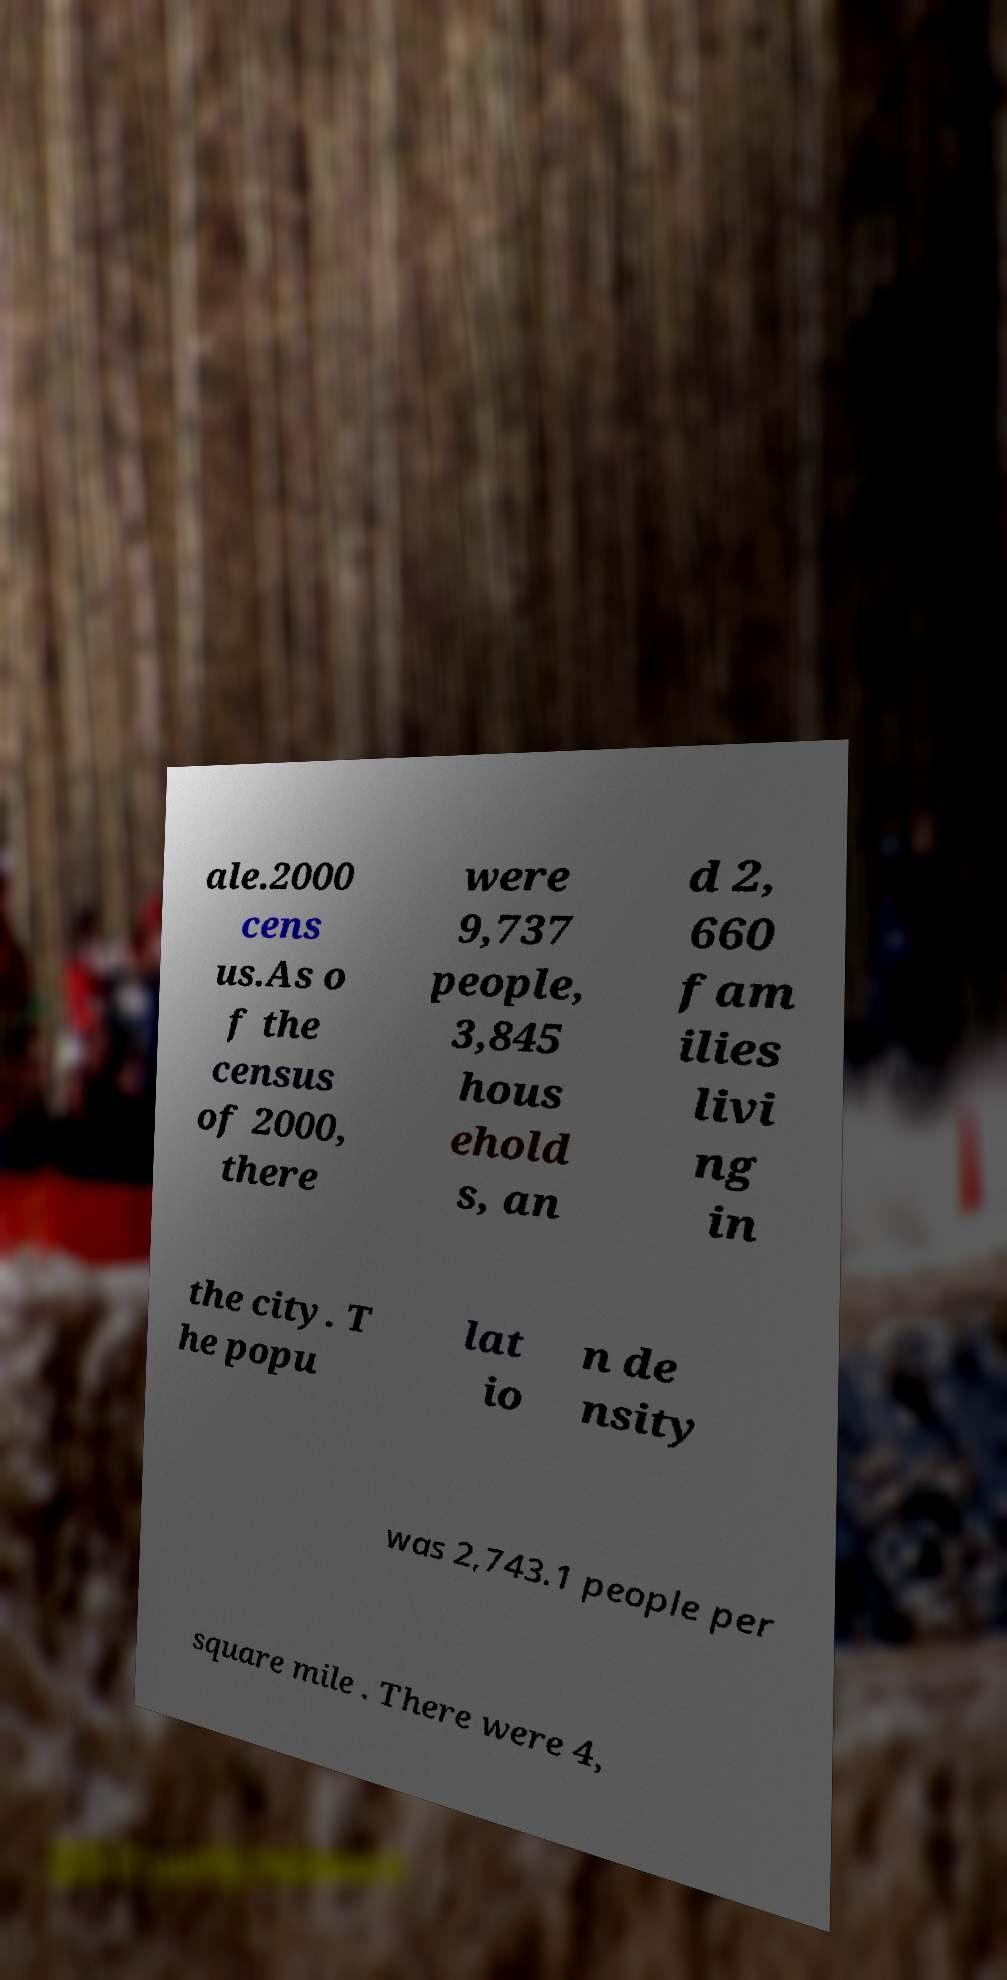There's text embedded in this image that I need extracted. Can you transcribe it verbatim? ale.2000 cens us.As o f the census of 2000, there were 9,737 people, 3,845 hous ehold s, an d 2, 660 fam ilies livi ng in the city. T he popu lat io n de nsity was 2,743.1 people per square mile . There were 4, 